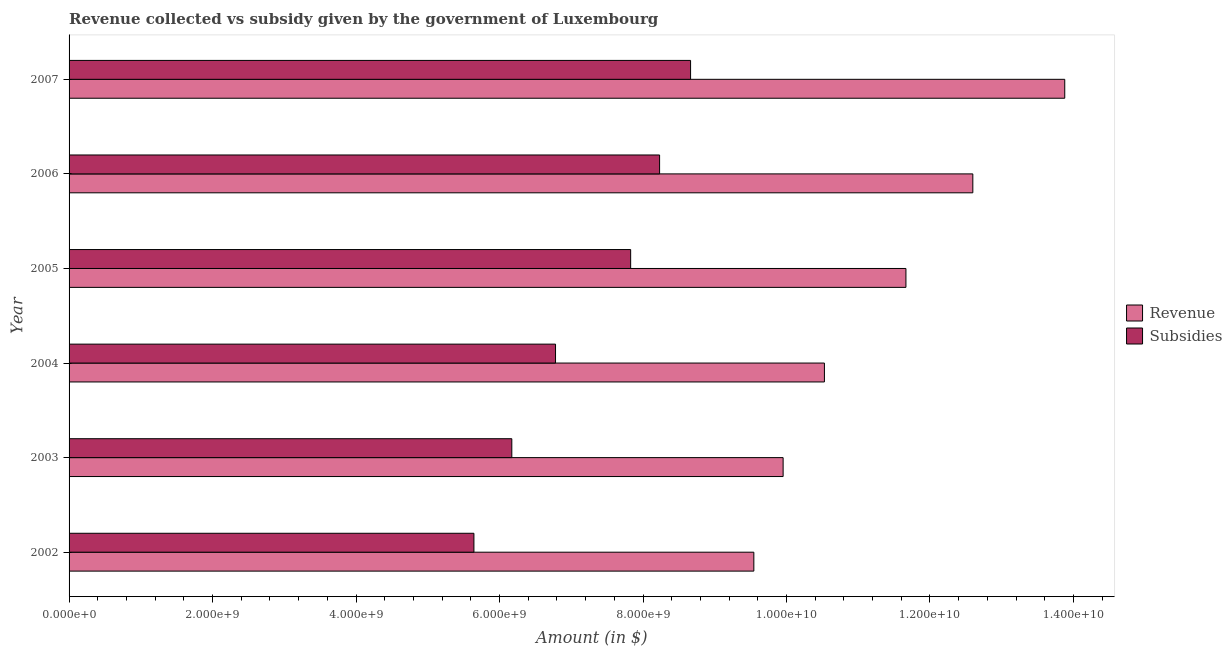How many bars are there on the 5th tick from the top?
Your answer should be compact. 2. How many bars are there on the 2nd tick from the bottom?
Offer a terse response. 2. What is the label of the 4th group of bars from the top?
Keep it short and to the point. 2004. What is the amount of revenue collected in 2007?
Your response must be concise. 1.39e+1. Across all years, what is the maximum amount of subsidies given?
Your response must be concise. 8.66e+09. Across all years, what is the minimum amount of subsidies given?
Your response must be concise. 5.64e+09. In which year was the amount of subsidies given minimum?
Give a very brief answer. 2002. What is the total amount of subsidies given in the graph?
Offer a terse response. 4.33e+1. What is the difference between the amount of revenue collected in 2004 and that in 2007?
Provide a short and direct response. -3.35e+09. What is the difference between the amount of revenue collected in 2007 and the amount of subsidies given in 2005?
Provide a succinct answer. 6.05e+09. What is the average amount of revenue collected per year?
Offer a very short reply. 1.14e+1. In the year 2003, what is the difference between the amount of revenue collected and amount of subsidies given?
Your answer should be very brief. 3.78e+09. What is the ratio of the amount of subsidies given in 2002 to that in 2006?
Your answer should be compact. 0.69. Is the amount of revenue collected in 2002 less than that in 2004?
Ensure brevity in your answer.  Yes. What is the difference between the highest and the second highest amount of revenue collected?
Give a very brief answer. 1.28e+09. What is the difference between the highest and the lowest amount of subsidies given?
Offer a terse response. 3.02e+09. In how many years, is the amount of revenue collected greater than the average amount of revenue collected taken over all years?
Give a very brief answer. 3. What does the 1st bar from the top in 2006 represents?
Offer a terse response. Subsidies. What does the 1st bar from the bottom in 2004 represents?
Give a very brief answer. Revenue. How many bars are there?
Provide a short and direct response. 12. How many years are there in the graph?
Keep it short and to the point. 6. What is the difference between two consecutive major ticks on the X-axis?
Make the answer very short. 2.00e+09. Are the values on the major ticks of X-axis written in scientific E-notation?
Provide a short and direct response. Yes. How are the legend labels stacked?
Make the answer very short. Vertical. What is the title of the graph?
Make the answer very short. Revenue collected vs subsidy given by the government of Luxembourg. Does "Electricity and heat production" appear as one of the legend labels in the graph?
Your answer should be very brief. No. What is the label or title of the X-axis?
Offer a terse response. Amount (in $). What is the Amount (in $) in Revenue in 2002?
Provide a succinct answer. 9.55e+09. What is the Amount (in $) of Subsidies in 2002?
Ensure brevity in your answer.  5.64e+09. What is the Amount (in $) of Revenue in 2003?
Ensure brevity in your answer.  9.95e+09. What is the Amount (in $) in Subsidies in 2003?
Your answer should be very brief. 6.17e+09. What is the Amount (in $) of Revenue in 2004?
Keep it short and to the point. 1.05e+1. What is the Amount (in $) of Subsidies in 2004?
Your answer should be very brief. 6.78e+09. What is the Amount (in $) of Revenue in 2005?
Give a very brief answer. 1.17e+1. What is the Amount (in $) of Subsidies in 2005?
Your answer should be compact. 7.83e+09. What is the Amount (in $) in Revenue in 2006?
Offer a terse response. 1.26e+1. What is the Amount (in $) of Subsidies in 2006?
Make the answer very short. 8.23e+09. What is the Amount (in $) of Revenue in 2007?
Keep it short and to the point. 1.39e+1. What is the Amount (in $) in Subsidies in 2007?
Offer a very short reply. 8.66e+09. Across all years, what is the maximum Amount (in $) in Revenue?
Offer a very short reply. 1.39e+1. Across all years, what is the maximum Amount (in $) of Subsidies?
Give a very brief answer. 8.66e+09. Across all years, what is the minimum Amount (in $) in Revenue?
Ensure brevity in your answer.  9.55e+09. Across all years, what is the minimum Amount (in $) of Subsidies?
Offer a terse response. 5.64e+09. What is the total Amount (in $) in Revenue in the graph?
Your response must be concise. 6.82e+1. What is the total Amount (in $) in Subsidies in the graph?
Provide a short and direct response. 4.33e+1. What is the difference between the Amount (in $) in Revenue in 2002 and that in 2003?
Your answer should be compact. -4.08e+08. What is the difference between the Amount (in $) of Subsidies in 2002 and that in 2003?
Give a very brief answer. -5.28e+08. What is the difference between the Amount (in $) in Revenue in 2002 and that in 2004?
Offer a terse response. -9.84e+08. What is the difference between the Amount (in $) of Subsidies in 2002 and that in 2004?
Your answer should be very brief. -1.14e+09. What is the difference between the Amount (in $) of Revenue in 2002 and that in 2005?
Offer a terse response. -2.12e+09. What is the difference between the Amount (in $) in Subsidies in 2002 and that in 2005?
Offer a terse response. -2.18e+09. What is the difference between the Amount (in $) of Revenue in 2002 and that in 2006?
Provide a succinct answer. -3.05e+09. What is the difference between the Amount (in $) in Subsidies in 2002 and that in 2006?
Offer a terse response. -2.59e+09. What is the difference between the Amount (in $) of Revenue in 2002 and that in 2007?
Keep it short and to the point. -4.33e+09. What is the difference between the Amount (in $) of Subsidies in 2002 and that in 2007?
Ensure brevity in your answer.  -3.02e+09. What is the difference between the Amount (in $) in Revenue in 2003 and that in 2004?
Keep it short and to the point. -5.76e+08. What is the difference between the Amount (in $) in Subsidies in 2003 and that in 2004?
Offer a terse response. -6.09e+08. What is the difference between the Amount (in $) of Revenue in 2003 and that in 2005?
Ensure brevity in your answer.  -1.71e+09. What is the difference between the Amount (in $) in Subsidies in 2003 and that in 2005?
Your answer should be very brief. -1.66e+09. What is the difference between the Amount (in $) in Revenue in 2003 and that in 2006?
Your answer should be very brief. -2.64e+09. What is the difference between the Amount (in $) of Subsidies in 2003 and that in 2006?
Give a very brief answer. -2.06e+09. What is the difference between the Amount (in $) in Revenue in 2003 and that in 2007?
Your response must be concise. -3.93e+09. What is the difference between the Amount (in $) of Subsidies in 2003 and that in 2007?
Offer a very short reply. -2.49e+09. What is the difference between the Amount (in $) of Revenue in 2004 and that in 2005?
Make the answer very short. -1.14e+09. What is the difference between the Amount (in $) of Subsidies in 2004 and that in 2005?
Keep it short and to the point. -1.05e+09. What is the difference between the Amount (in $) of Revenue in 2004 and that in 2006?
Your response must be concise. -2.07e+09. What is the difference between the Amount (in $) of Subsidies in 2004 and that in 2006?
Provide a short and direct response. -1.45e+09. What is the difference between the Amount (in $) in Revenue in 2004 and that in 2007?
Ensure brevity in your answer.  -3.35e+09. What is the difference between the Amount (in $) in Subsidies in 2004 and that in 2007?
Offer a terse response. -1.88e+09. What is the difference between the Amount (in $) in Revenue in 2005 and that in 2006?
Your answer should be compact. -9.32e+08. What is the difference between the Amount (in $) of Subsidies in 2005 and that in 2006?
Offer a terse response. -4.03e+08. What is the difference between the Amount (in $) of Revenue in 2005 and that in 2007?
Make the answer very short. -2.21e+09. What is the difference between the Amount (in $) in Subsidies in 2005 and that in 2007?
Offer a very short reply. -8.35e+08. What is the difference between the Amount (in $) of Revenue in 2006 and that in 2007?
Provide a succinct answer. -1.28e+09. What is the difference between the Amount (in $) in Subsidies in 2006 and that in 2007?
Offer a very short reply. -4.32e+08. What is the difference between the Amount (in $) in Revenue in 2002 and the Amount (in $) in Subsidies in 2003?
Provide a succinct answer. 3.37e+09. What is the difference between the Amount (in $) of Revenue in 2002 and the Amount (in $) of Subsidies in 2004?
Your answer should be very brief. 2.76e+09. What is the difference between the Amount (in $) of Revenue in 2002 and the Amount (in $) of Subsidies in 2005?
Give a very brief answer. 1.72e+09. What is the difference between the Amount (in $) in Revenue in 2002 and the Amount (in $) in Subsidies in 2006?
Make the answer very short. 1.31e+09. What is the difference between the Amount (in $) in Revenue in 2002 and the Amount (in $) in Subsidies in 2007?
Your answer should be compact. 8.82e+08. What is the difference between the Amount (in $) in Revenue in 2003 and the Amount (in $) in Subsidies in 2004?
Provide a succinct answer. 3.17e+09. What is the difference between the Amount (in $) of Revenue in 2003 and the Amount (in $) of Subsidies in 2005?
Your response must be concise. 2.13e+09. What is the difference between the Amount (in $) in Revenue in 2003 and the Amount (in $) in Subsidies in 2006?
Ensure brevity in your answer.  1.72e+09. What is the difference between the Amount (in $) of Revenue in 2003 and the Amount (in $) of Subsidies in 2007?
Your answer should be compact. 1.29e+09. What is the difference between the Amount (in $) in Revenue in 2004 and the Amount (in $) in Subsidies in 2005?
Your response must be concise. 2.70e+09. What is the difference between the Amount (in $) of Revenue in 2004 and the Amount (in $) of Subsidies in 2006?
Offer a terse response. 2.30e+09. What is the difference between the Amount (in $) in Revenue in 2004 and the Amount (in $) in Subsidies in 2007?
Provide a succinct answer. 1.87e+09. What is the difference between the Amount (in $) in Revenue in 2005 and the Amount (in $) in Subsidies in 2006?
Ensure brevity in your answer.  3.43e+09. What is the difference between the Amount (in $) of Revenue in 2005 and the Amount (in $) of Subsidies in 2007?
Offer a very short reply. 3.00e+09. What is the difference between the Amount (in $) in Revenue in 2006 and the Amount (in $) in Subsidies in 2007?
Your response must be concise. 3.93e+09. What is the average Amount (in $) in Revenue per year?
Provide a short and direct response. 1.14e+1. What is the average Amount (in $) in Subsidies per year?
Offer a very short reply. 7.22e+09. In the year 2002, what is the difference between the Amount (in $) in Revenue and Amount (in $) in Subsidies?
Offer a very short reply. 3.90e+09. In the year 2003, what is the difference between the Amount (in $) of Revenue and Amount (in $) of Subsidies?
Keep it short and to the point. 3.78e+09. In the year 2004, what is the difference between the Amount (in $) in Revenue and Amount (in $) in Subsidies?
Offer a terse response. 3.75e+09. In the year 2005, what is the difference between the Amount (in $) of Revenue and Amount (in $) of Subsidies?
Offer a very short reply. 3.84e+09. In the year 2006, what is the difference between the Amount (in $) in Revenue and Amount (in $) in Subsidies?
Your answer should be very brief. 4.37e+09. In the year 2007, what is the difference between the Amount (in $) in Revenue and Amount (in $) in Subsidies?
Make the answer very short. 5.22e+09. What is the ratio of the Amount (in $) of Revenue in 2002 to that in 2003?
Provide a succinct answer. 0.96. What is the ratio of the Amount (in $) of Subsidies in 2002 to that in 2003?
Provide a succinct answer. 0.91. What is the ratio of the Amount (in $) of Revenue in 2002 to that in 2004?
Ensure brevity in your answer.  0.91. What is the ratio of the Amount (in $) of Subsidies in 2002 to that in 2004?
Your answer should be very brief. 0.83. What is the ratio of the Amount (in $) in Revenue in 2002 to that in 2005?
Ensure brevity in your answer.  0.82. What is the ratio of the Amount (in $) of Subsidies in 2002 to that in 2005?
Make the answer very short. 0.72. What is the ratio of the Amount (in $) of Revenue in 2002 to that in 2006?
Provide a succinct answer. 0.76. What is the ratio of the Amount (in $) in Subsidies in 2002 to that in 2006?
Provide a short and direct response. 0.69. What is the ratio of the Amount (in $) in Revenue in 2002 to that in 2007?
Offer a terse response. 0.69. What is the ratio of the Amount (in $) of Subsidies in 2002 to that in 2007?
Your response must be concise. 0.65. What is the ratio of the Amount (in $) of Revenue in 2003 to that in 2004?
Your answer should be very brief. 0.95. What is the ratio of the Amount (in $) in Subsidies in 2003 to that in 2004?
Offer a terse response. 0.91. What is the ratio of the Amount (in $) of Revenue in 2003 to that in 2005?
Give a very brief answer. 0.85. What is the ratio of the Amount (in $) in Subsidies in 2003 to that in 2005?
Offer a very short reply. 0.79. What is the ratio of the Amount (in $) of Revenue in 2003 to that in 2006?
Your response must be concise. 0.79. What is the ratio of the Amount (in $) in Subsidies in 2003 to that in 2006?
Ensure brevity in your answer.  0.75. What is the ratio of the Amount (in $) in Revenue in 2003 to that in 2007?
Provide a short and direct response. 0.72. What is the ratio of the Amount (in $) in Subsidies in 2003 to that in 2007?
Offer a terse response. 0.71. What is the ratio of the Amount (in $) in Revenue in 2004 to that in 2005?
Give a very brief answer. 0.9. What is the ratio of the Amount (in $) in Subsidies in 2004 to that in 2005?
Ensure brevity in your answer.  0.87. What is the ratio of the Amount (in $) in Revenue in 2004 to that in 2006?
Provide a succinct answer. 0.84. What is the ratio of the Amount (in $) of Subsidies in 2004 to that in 2006?
Give a very brief answer. 0.82. What is the ratio of the Amount (in $) of Revenue in 2004 to that in 2007?
Offer a very short reply. 0.76. What is the ratio of the Amount (in $) in Subsidies in 2004 to that in 2007?
Offer a terse response. 0.78. What is the ratio of the Amount (in $) in Revenue in 2005 to that in 2006?
Keep it short and to the point. 0.93. What is the ratio of the Amount (in $) in Subsidies in 2005 to that in 2006?
Make the answer very short. 0.95. What is the ratio of the Amount (in $) of Revenue in 2005 to that in 2007?
Provide a short and direct response. 0.84. What is the ratio of the Amount (in $) in Subsidies in 2005 to that in 2007?
Provide a short and direct response. 0.9. What is the ratio of the Amount (in $) of Revenue in 2006 to that in 2007?
Your answer should be compact. 0.91. What is the ratio of the Amount (in $) in Subsidies in 2006 to that in 2007?
Give a very brief answer. 0.95. What is the difference between the highest and the second highest Amount (in $) of Revenue?
Your answer should be very brief. 1.28e+09. What is the difference between the highest and the second highest Amount (in $) in Subsidies?
Ensure brevity in your answer.  4.32e+08. What is the difference between the highest and the lowest Amount (in $) of Revenue?
Ensure brevity in your answer.  4.33e+09. What is the difference between the highest and the lowest Amount (in $) in Subsidies?
Provide a short and direct response. 3.02e+09. 